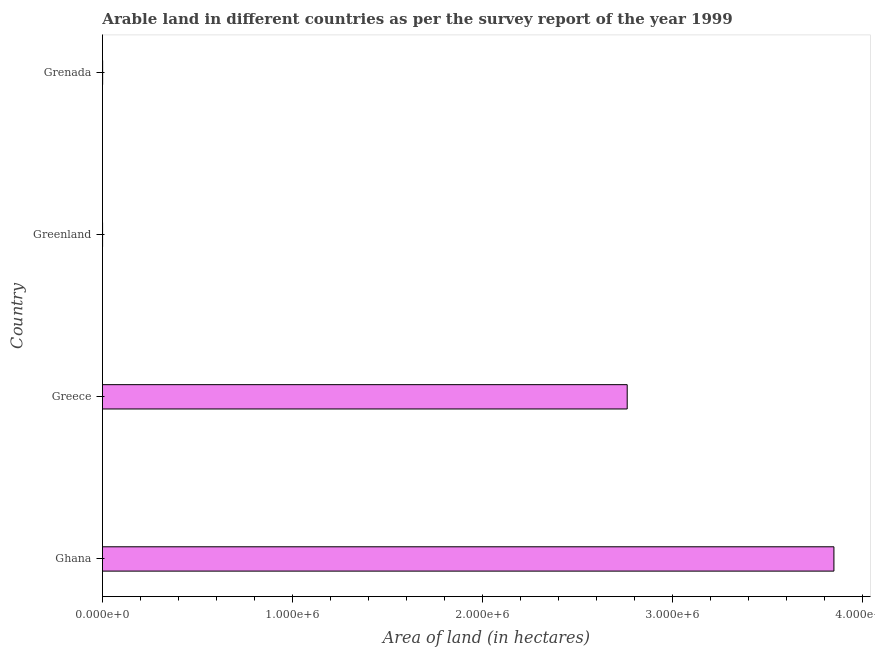What is the title of the graph?
Keep it short and to the point. Arable land in different countries as per the survey report of the year 1999. What is the label or title of the X-axis?
Provide a succinct answer. Area of land (in hectares). What is the label or title of the Y-axis?
Your response must be concise. Country. What is the area of land in Greenland?
Your response must be concise. 700. Across all countries, what is the maximum area of land?
Your answer should be very brief. 3.85e+06. Across all countries, what is the minimum area of land?
Your response must be concise. 700. In which country was the area of land minimum?
Ensure brevity in your answer.  Greenland. What is the sum of the area of land?
Provide a succinct answer. 6.61e+06. What is the difference between the area of land in Ghana and Greenland?
Your answer should be compact. 3.85e+06. What is the average area of land per country?
Give a very brief answer. 1.65e+06. What is the median area of land?
Offer a very short reply. 1.38e+06. In how many countries, is the area of land greater than 1200000 hectares?
Ensure brevity in your answer.  2. What is the ratio of the area of land in Ghana to that in Grenada?
Provide a short and direct response. 3850. Is the area of land in Ghana less than that in Greece?
Provide a short and direct response. No. Is the difference between the area of land in Greece and Greenland greater than the difference between any two countries?
Your response must be concise. No. What is the difference between the highest and the second highest area of land?
Ensure brevity in your answer.  1.09e+06. What is the difference between the highest and the lowest area of land?
Keep it short and to the point. 3.85e+06. In how many countries, is the area of land greater than the average area of land taken over all countries?
Provide a short and direct response. 2. How many bars are there?
Ensure brevity in your answer.  4. Are all the bars in the graph horizontal?
Keep it short and to the point. Yes. What is the Area of land (in hectares) in Ghana?
Offer a very short reply. 3.85e+06. What is the Area of land (in hectares) in Greece?
Make the answer very short. 2.76e+06. What is the Area of land (in hectares) in Greenland?
Ensure brevity in your answer.  700. What is the difference between the Area of land (in hectares) in Ghana and Greece?
Provide a succinct answer. 1.09e+06. What is the difference between the Area of land (in hectares) in Ghana and Greenland?
Offer a terse response. 3.85e+06. What is the difference between the Area of land (in hectares) in Ghana and Grenada?
Offer a very short reply. 3.85e+06. What is the difference between the Area of land (in hectares) in Greece and Greenland?
Offer a very short reply. 2.76e+06. What is the difference between the Area of land (in hectares) in Greece and Grenada?
Your answer should be very brief. 2.76e+06. What is the difference between the Area of land (in hectares) in Greenland and Grenada?
Make the answer very short. -300. What is the ratio of the Area of land (in hectares) in Ghana to that in Greece?
Give a very brief answer. 1.39. What is the ratio of the Area of land (in hectares) in Ghana to that in Greenland?
Offer a terse response. 5500. What is the ratio of the Area of land (in hectares) in Ghana to that in Grenada?
Your answer should be very brief. 3850. What is the ratio of the Area of land (in hectares) in Greece to that in Greenland?
Offer a very short reply. 3945.71. What is the ratio of the Area of land (in hectares) in Greece to that in Grenada?
Your answer should be very brief. 2762. 